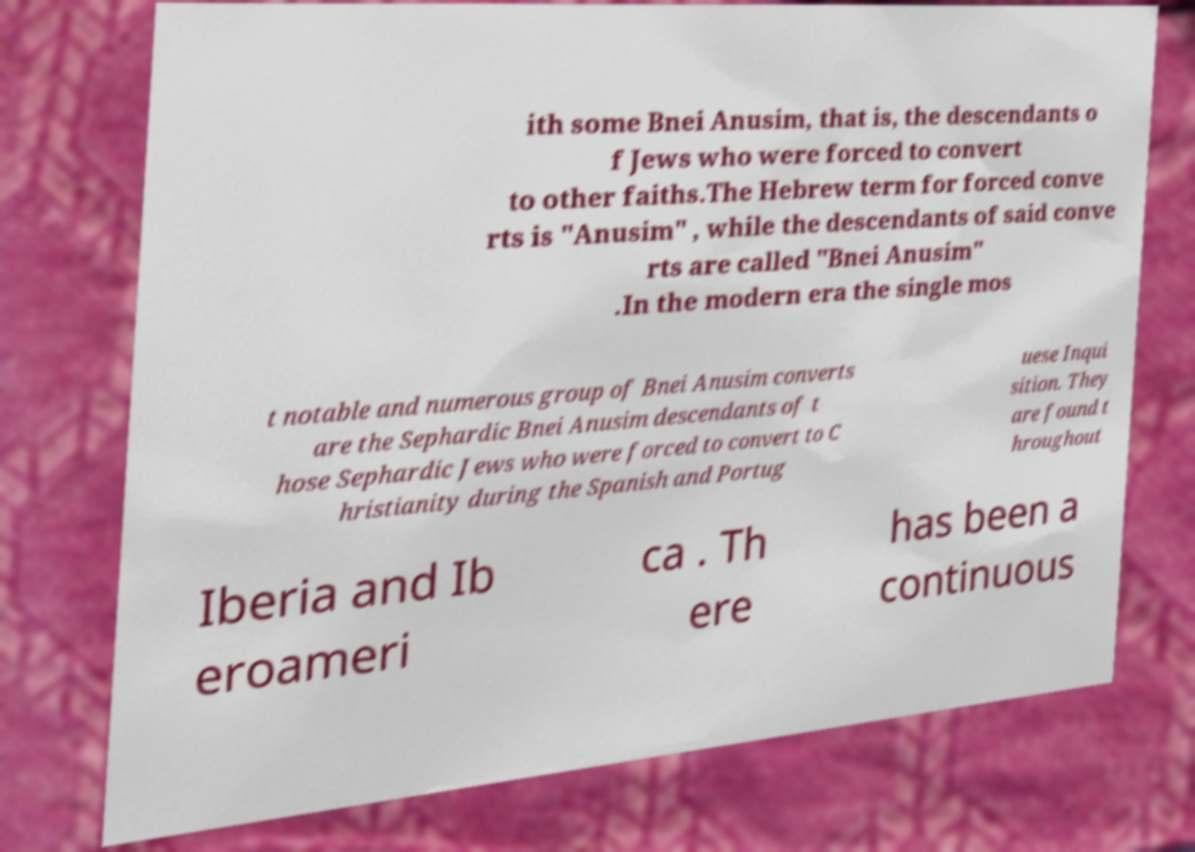Can you read and provide the text displayed in the image?This photo seems to have some interesting text. Can you extract and type it out for me? ith some Bnei Anusim, that is, the descendants o f Jews who were forced to convert to other faiths.The Hebrew term for forced conve rts is "Anusim" , while the descendants of said conve rts are called "Bnei Anusim" .In the modern era the single mos t notable and numerous group of Bnei Anusim converts are the Sephardic Bnei Anusim descendants of t hose Sephardic Jews who were forced to convert to C hristianity during the Spanish and Portug uese Inqui sition. They are found t hroughout Iberia and Ib eroameri ca . Th ere has been a continuous 